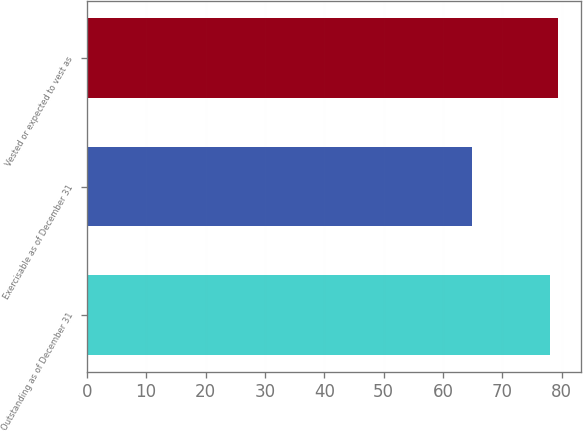Convert chart to OTSL. <chart><loc_0><loc_0><loc_500><loc_500><bar_chart><fcel>Outstanding as of December 31<fcel>Exercisable as of December 31<fcel>Vested or expected to vest as<nl><fcel>78<fcel>64.93<fcel>79.31<nl></chart> 